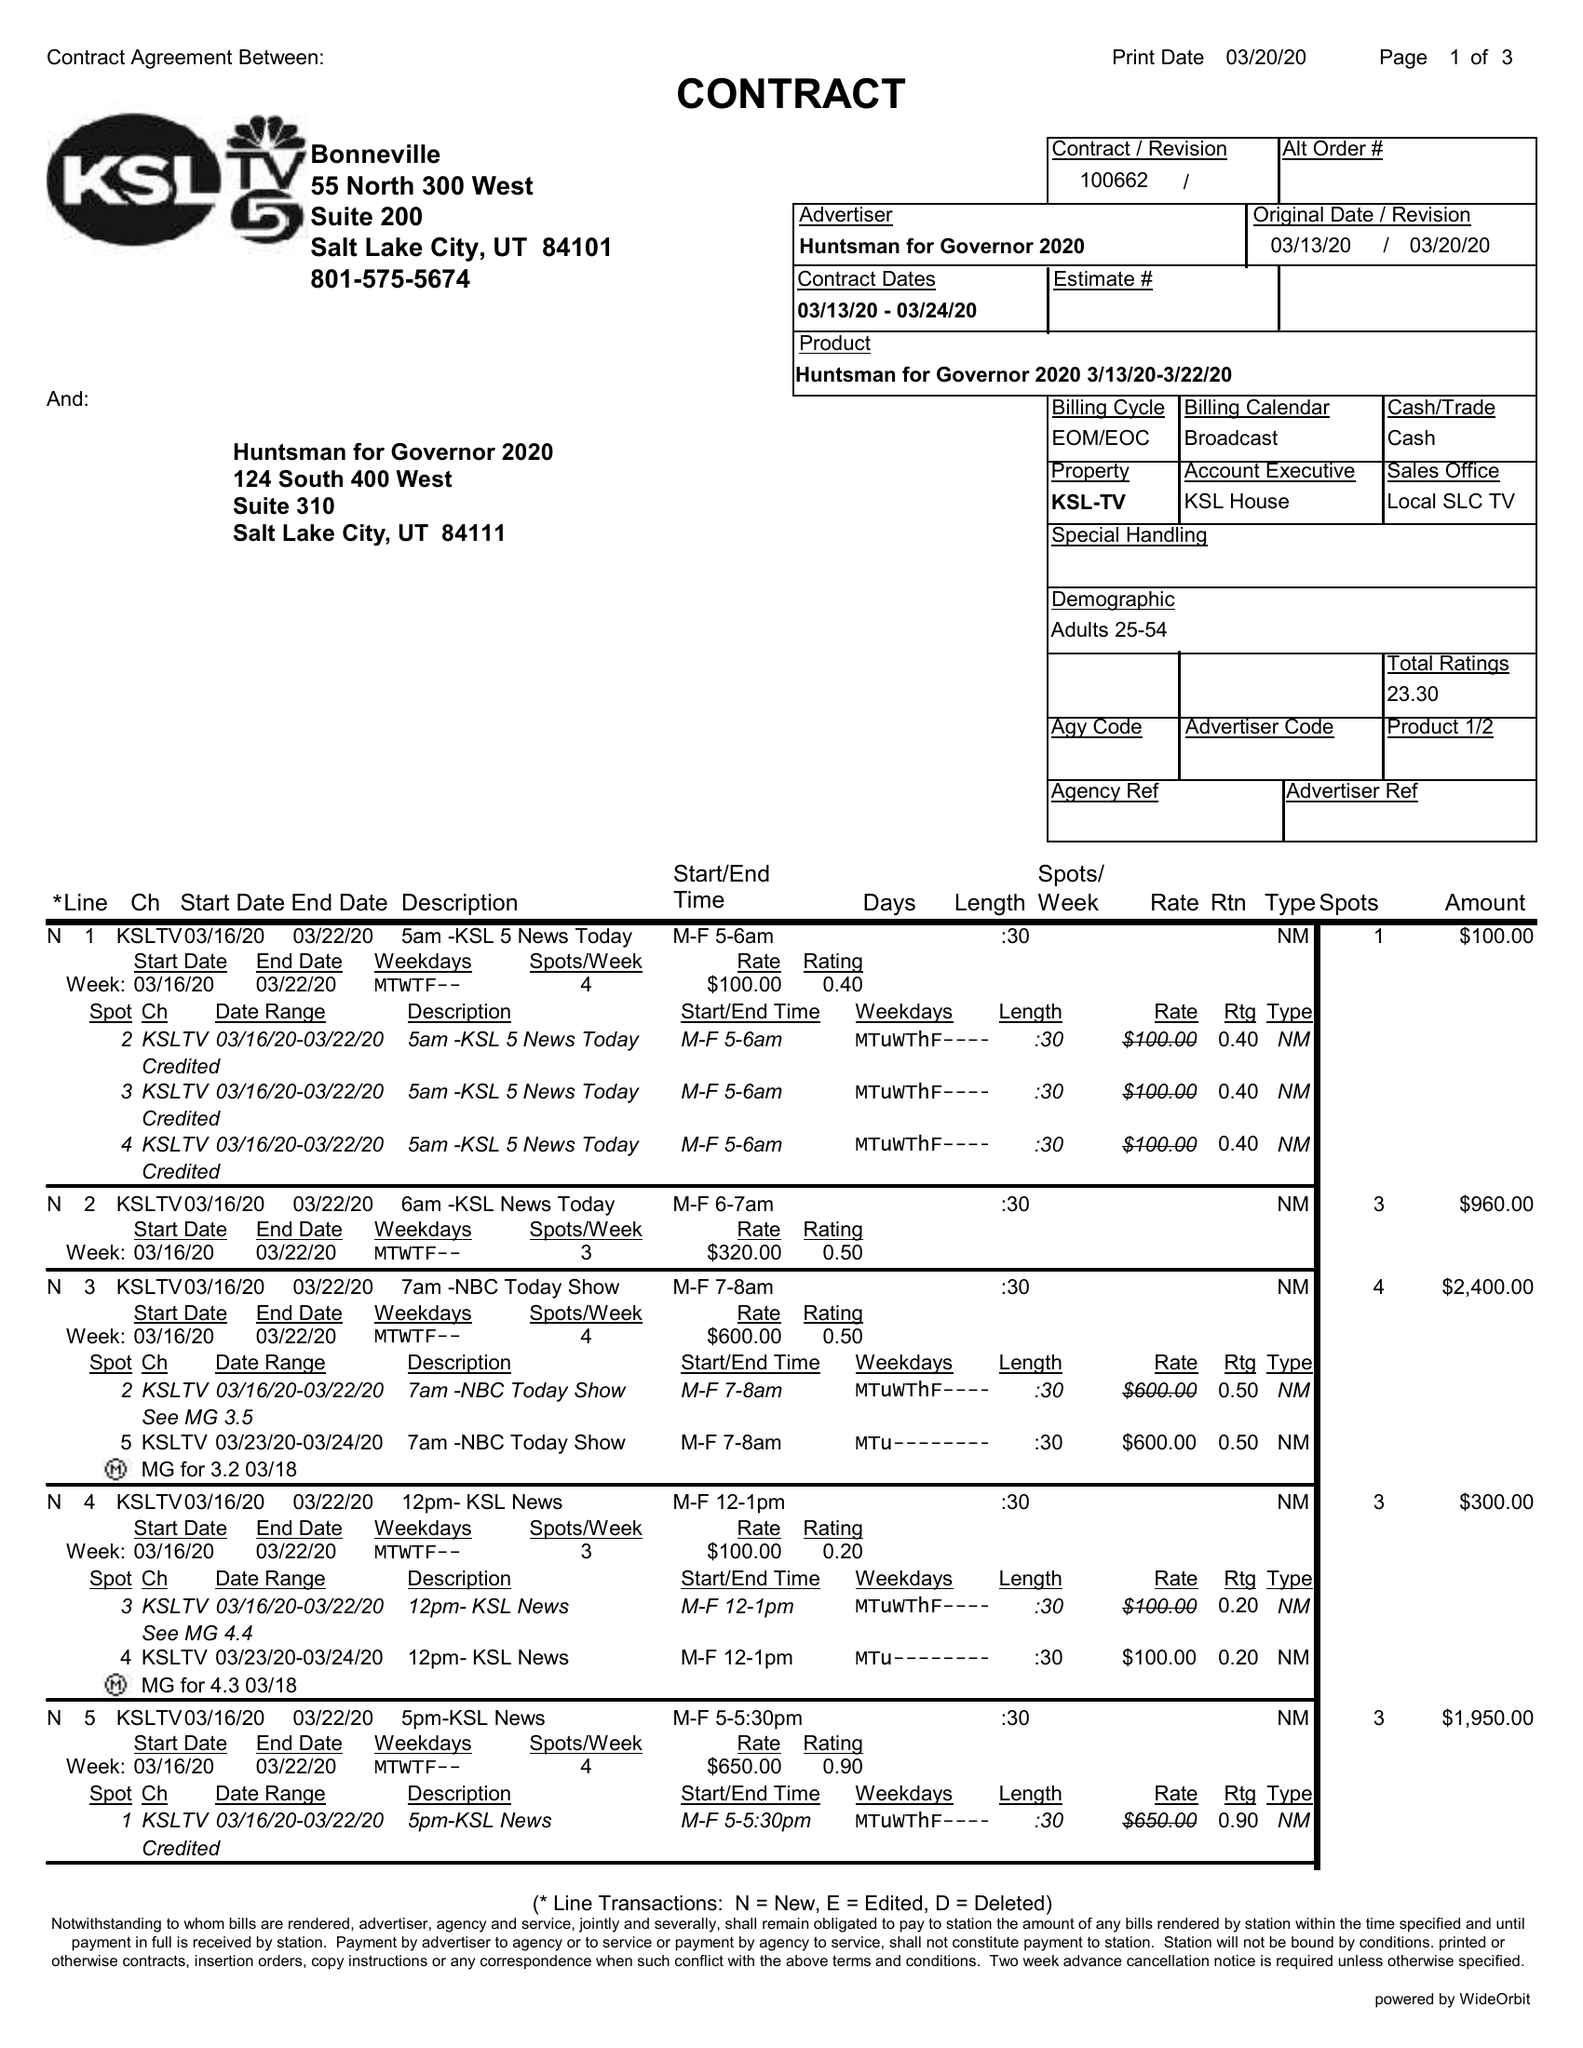What is the value for the flight_to?
Answer the question using a single word or phrase. 03/24/20 